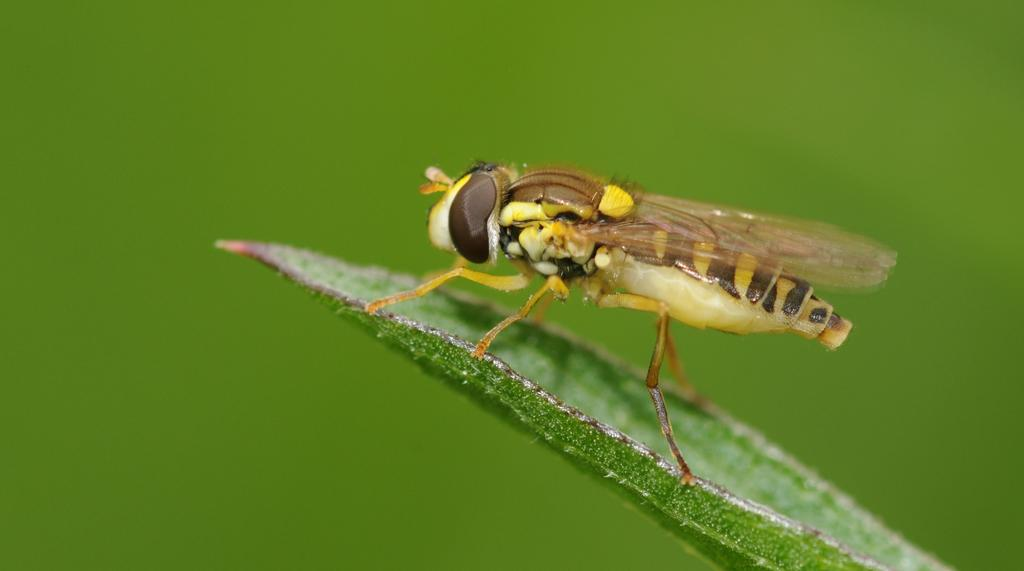What is the main subject of the image? The main subject of the image is a leaf. Is there anything else present on the leaf? Yes, there is an insect on the leaf. Can you describe the background of the image? The background of the image is blurred. What type of arm is visible in the image? There is no arm present in the image; it features a leaf with an insect on it. What type of servant can be seen attending to the insect in the image? There is no servant present in the image; it features a leaf with an insect on it. 